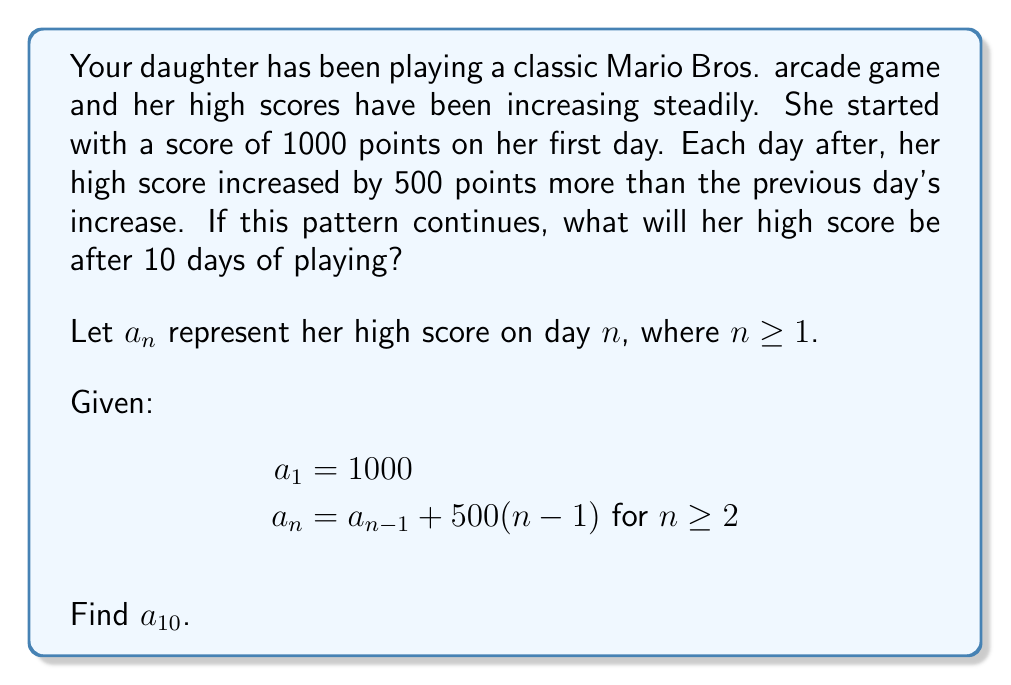What is the answer to this math problem? Let's approach this step-by-step:

1) First, we need to recognize that this is an arithmetic sequence with a variable common difference. The common difference between each term increases by 500 each time.

2) Let's write out the first few terms to see the pattern:

   $a_1 = 1000$
   $a_2 = a_1 + 500(1) = 1000 + 500 = 1500$
   $a_3 = a_2 + 500(2) = 1500 + 1000 = 2500$
   $a_4 = a_3 + 500(3) = 2500 + 1500 = 4000$

3) We can see that this forms an arithmetic sequence of the second order. The general formula for such a sequence is:

   $a_n = a_1 + \frac{n(n-1)}{2}d$

   where $d$ is the common difference of the sequence of differences.

4) In our case, $a_1 = 1000$ and $d = 500$. Substituting these values:

   $a_n = 1000 + \frac{n(n-1)}{2}(500)$

5) Simplifying:

   $a_n = 1000 + 250n(n-1)$
   $a_n = 1000 + 250(n^2 - n)$
   $a_n = 1000 + 250n^2 - 250n$

6) Now, to find $a_{10}$, we simply substitute $n = 10$:

   $a_{10} = 1000 + 250(10^2) - 250(10)$
   $a_{10} = 1000 + 25000 - 2500$
   $a_{10} = 23500$

Therefore, after 10 days, your daughter's high score will be 23,500 points.
Answer: $a_{10} = 23500$ points 